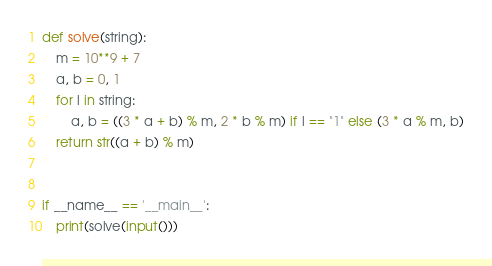<code> <loc_0><loc_0><loc_500><loc_500><_Python_>def solve(string):
    m = 10**9 + 7
    a, b = 0, 1
    for l in string:
        a, b = ((3 * a + b) % m, 2 * b % m) if l == "1" else (3 * a % m, b)
    return str((a + b) % m)


if __name__ == '__main__':
    print(solve(input()))
</code> 